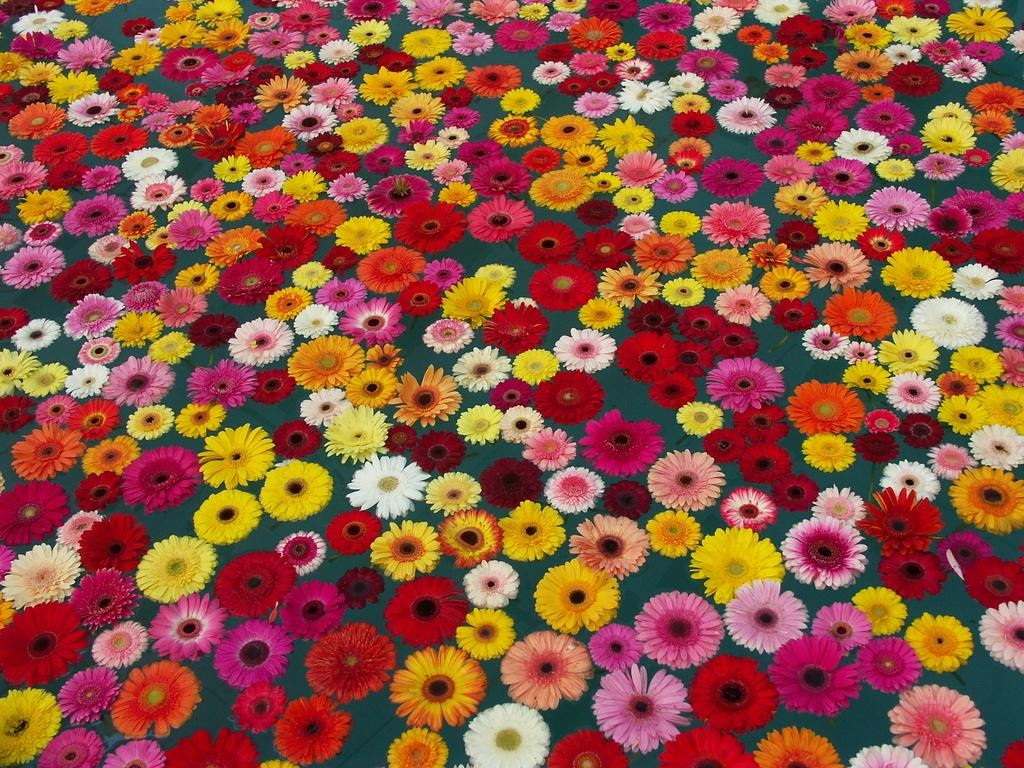What type of living organisms can be seen in the image? There are flowers in the image. How many different colors can be observed in the flowers? The flowers are in different colors. How are the flowers positioned in the image? The flowers are arranged on the water. What is the color of the background in the image? The background of the image is gray in color. What type of club can be seen in the image? There is no club present in the image; it features flowers arranged on water with a gray background. 